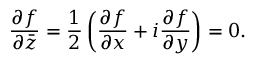Convert formula to latex. <formula><loc_0><loc_0><loc_500><loc_500>{ \frac { \partial f } { \partial { \bar { z } } } } = { \frac { 1 } { 2 } } \left ( { \frac { \partial f } { \partial x } } + i { \frac { \partial f } { \partial y } } \right ) = 0 .</formula> 